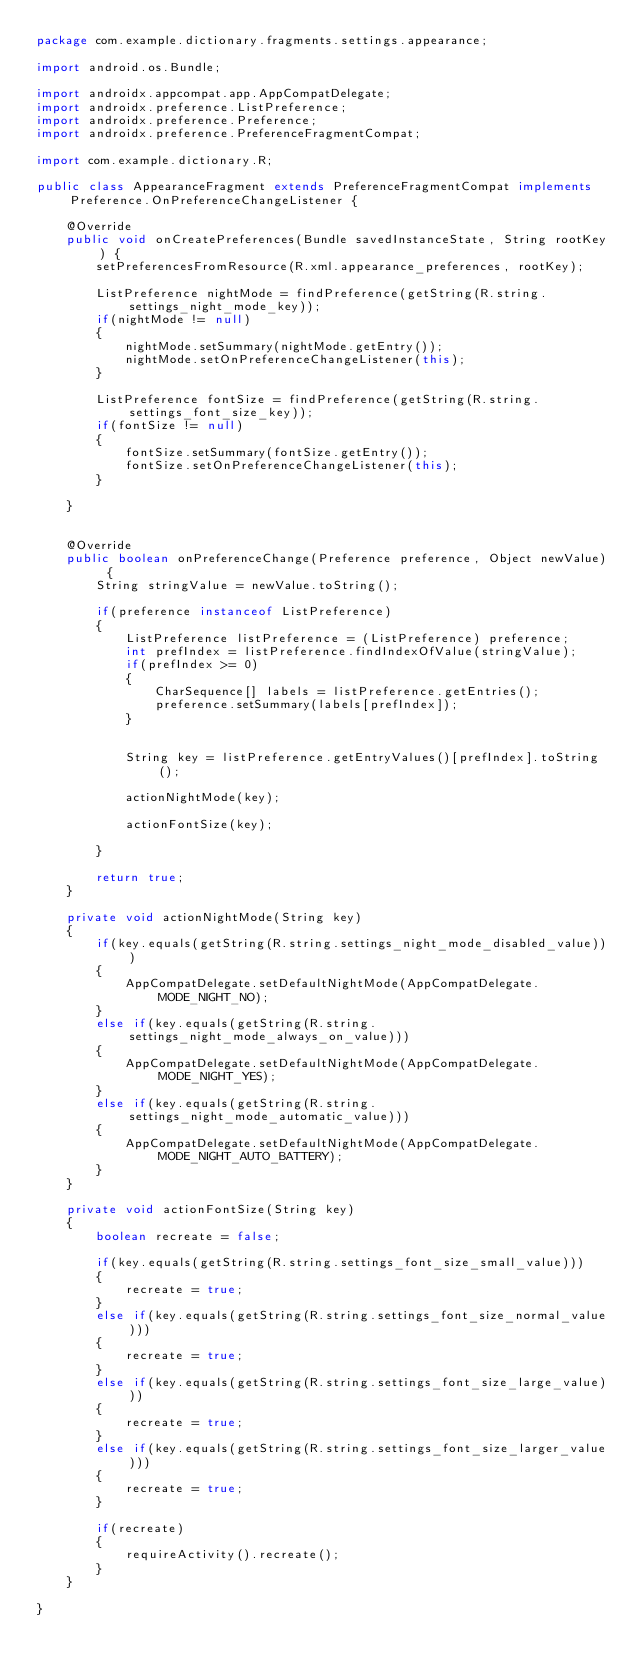<code> <loc_0><loc_0><loc_500><loc_500><_Java_>package com.example.dictionary.fragments.settings.appearance;

import android.os.Bundle;

import androidx.appcompat.app.AppCompatDelegate;
import androidx.preference.ListPreference;
import androidx.preference.Preference;
import androidx.preference.PreferenceFragmentCompat;

import com.example.dictionary.R;

public class AppearanceFragment extends PreferenceFragmentCompat implements Preference.OnPreferenceChangeListener {

    @Override
    public void onCreatePreferences(Bundle savedInstanceState, String rootKey) {
        setPreferencesFromResource(R.xml.appearance_preferences, rootKey);

        ListPreference nightMode = findPreference(getString(R.string.settings_night_mode_key));
        if(nightMode != null)
        {
            nightMode.setSummary(nightMode.getEntry());
            nightMode.setOnPreferenceChangeListener(this);
        }

        ListPreference fontSize = findPreference(getString(R.string.settings_font_size_key));
        if(fontSize != null)
        {
            fontSize.setSummary(fontSize.getEntry());
            fontSize.setOnPreferenceChangeListener(this);
        }

    }


    @Override
    public boolean onPreferenceChange(Preference preference, Object newValue) {
        String stringValue = newValue.toString();

        if(preference instanceof ListPreference)
        {
            ListPreference listPreference = (ListPreference) preference;
            int prefIndex = listPreference.findIndexOfValue(stringValue);
            if(prefIndex >= 0)
            {
                CharSequence[] labels = listPreference.getEntries();
                preference.setSummary(labels[prefIndex]);
            }


            String key = listPreference.getEntryValues()[prefIndex].toString();

            actionNightMode(key);

            actionFontSize(key);

        }

        return true;
    }

    private void actionNightMode(String key)
    {
        if(key.equals(getString(R.string.settings_night_mode_disabled_value)))
        {
            AppCompatDelegate.setDefaultNightMode(AppCompatDelegate.MODE_NIGHT_NO);
        }
        else if(key.equals(getString(R.string.settings_night_mode_always_on_value)))
        {
            AppCompatDelegate.setDefaultNightMode(AppCompatDelegate.MODE_NIGHT_YES);
        }
        else if(key.equals(getString(R.string.settings_night_mode_automatic_value)))
        {
            AppCompatDelegate.setDefaultNightMode(AppCompatDelegate.MODE_NIGHT_AUTO_BATTERY);
        }
    }

    private void actionFontSize(String key)
    {
        boolean recreate = false;

        if(key.equals(getString(R.string.settings_font_size_small_value)))
        {
            recreate = true;
        }
        else if(key.equals(getString(R.string.settings_font_size_normal_value)))
        {
            recreate = true;
        }
        else if(key.equals(getString(R.string.settings_font_size_large_value)))
        {
            recreate = true;
        }
        else if(key.equals(getString(R.string.settings_font_size_larger_value)))
        {
            recreate = true;
        }

        if(recreate)
        {
            requireActivity().recreate();
        }
    }

}
</code> 